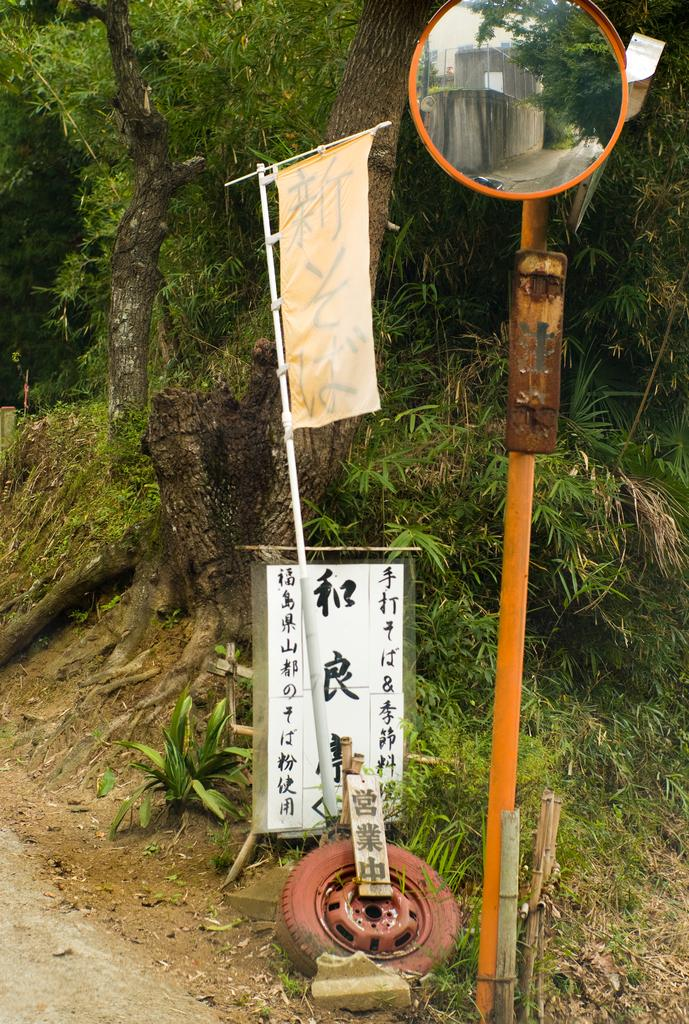What is the main object in the center of the image? There is a pole in the center of the image. What is attached to the pole? A mirror is attached to the pole. What can be seen in the background of the image? There are trees in the background of the image. What is on the ground in the image? There is a tire and grass on the ground. What type of weather can be seen in the image? The provided facts do not mention any weather conditions, so it cannot be determined from the image. 